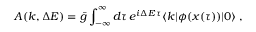<formula> <loc_0><loc_0><loc_500><loc_500>A ( k , \Delta E ) = \bar { g } \int _ { - \infty } ^ { \infty } d \tau \, e ^ { i \Delta E \, \tau } \langle k | \phi ( x ( \tau ) ) | 0 \rangle \, ,</formula> 